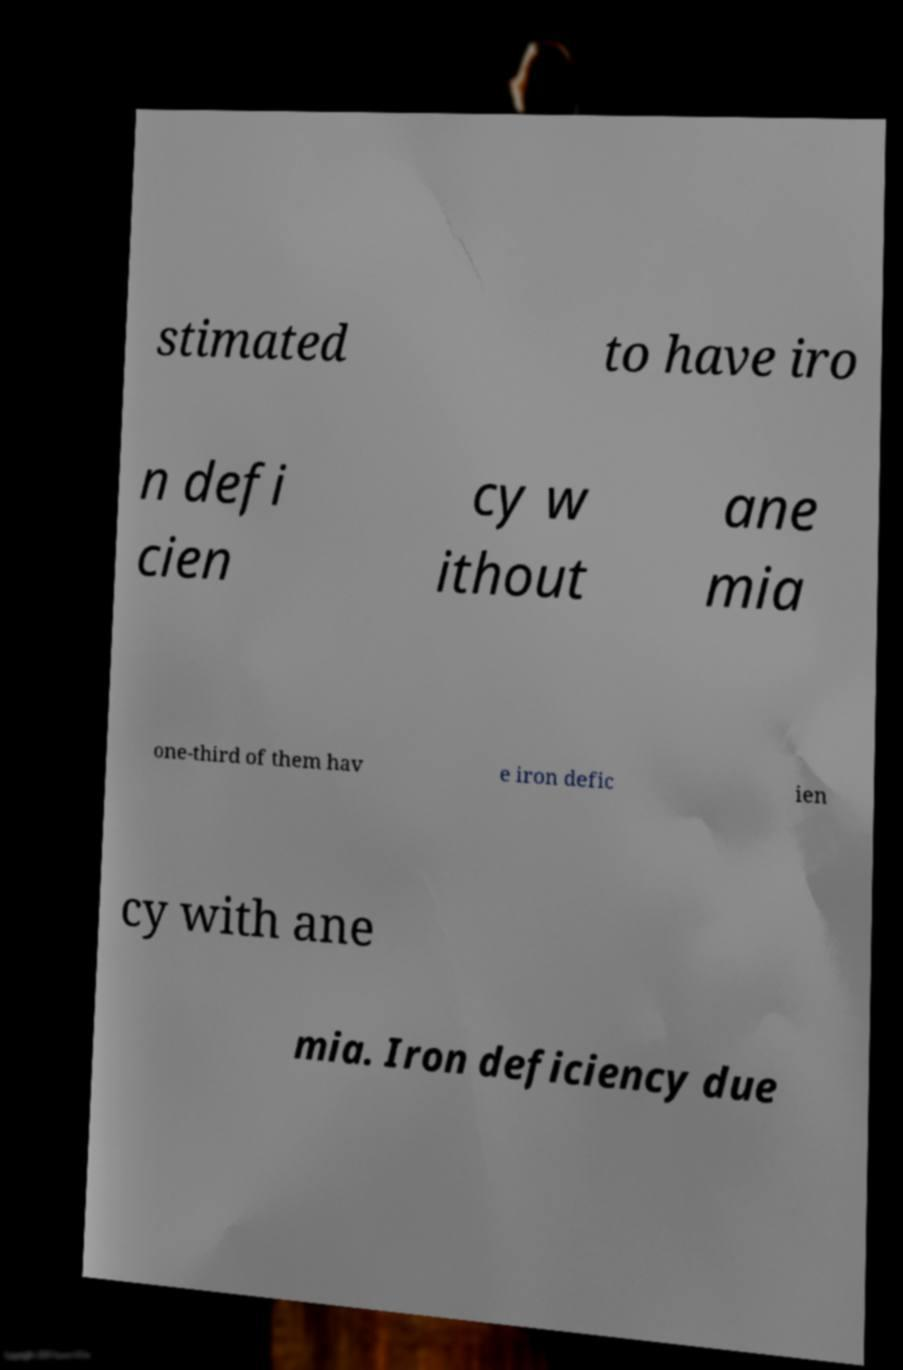Could you assist in decoding the text presented in this image and type it out clearly? stimated to have iro n defi cien cy w ithout ane mia one-third of them hav e iron defic ien cy with ane mia. Iron deficiency due 